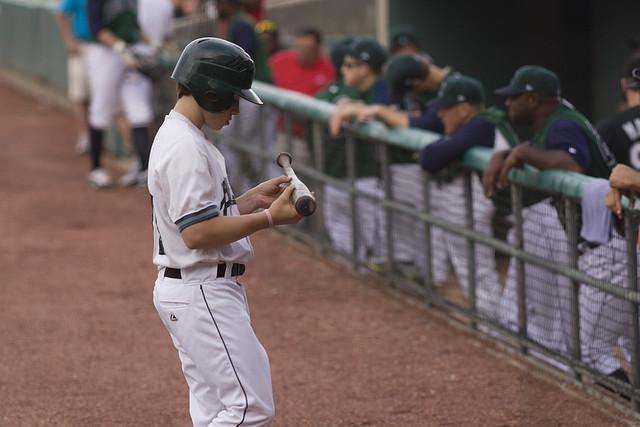What is the young man holding?

Choices:
A) book
B) baseball bat
C) fish
D) fishing rod baseball bat 